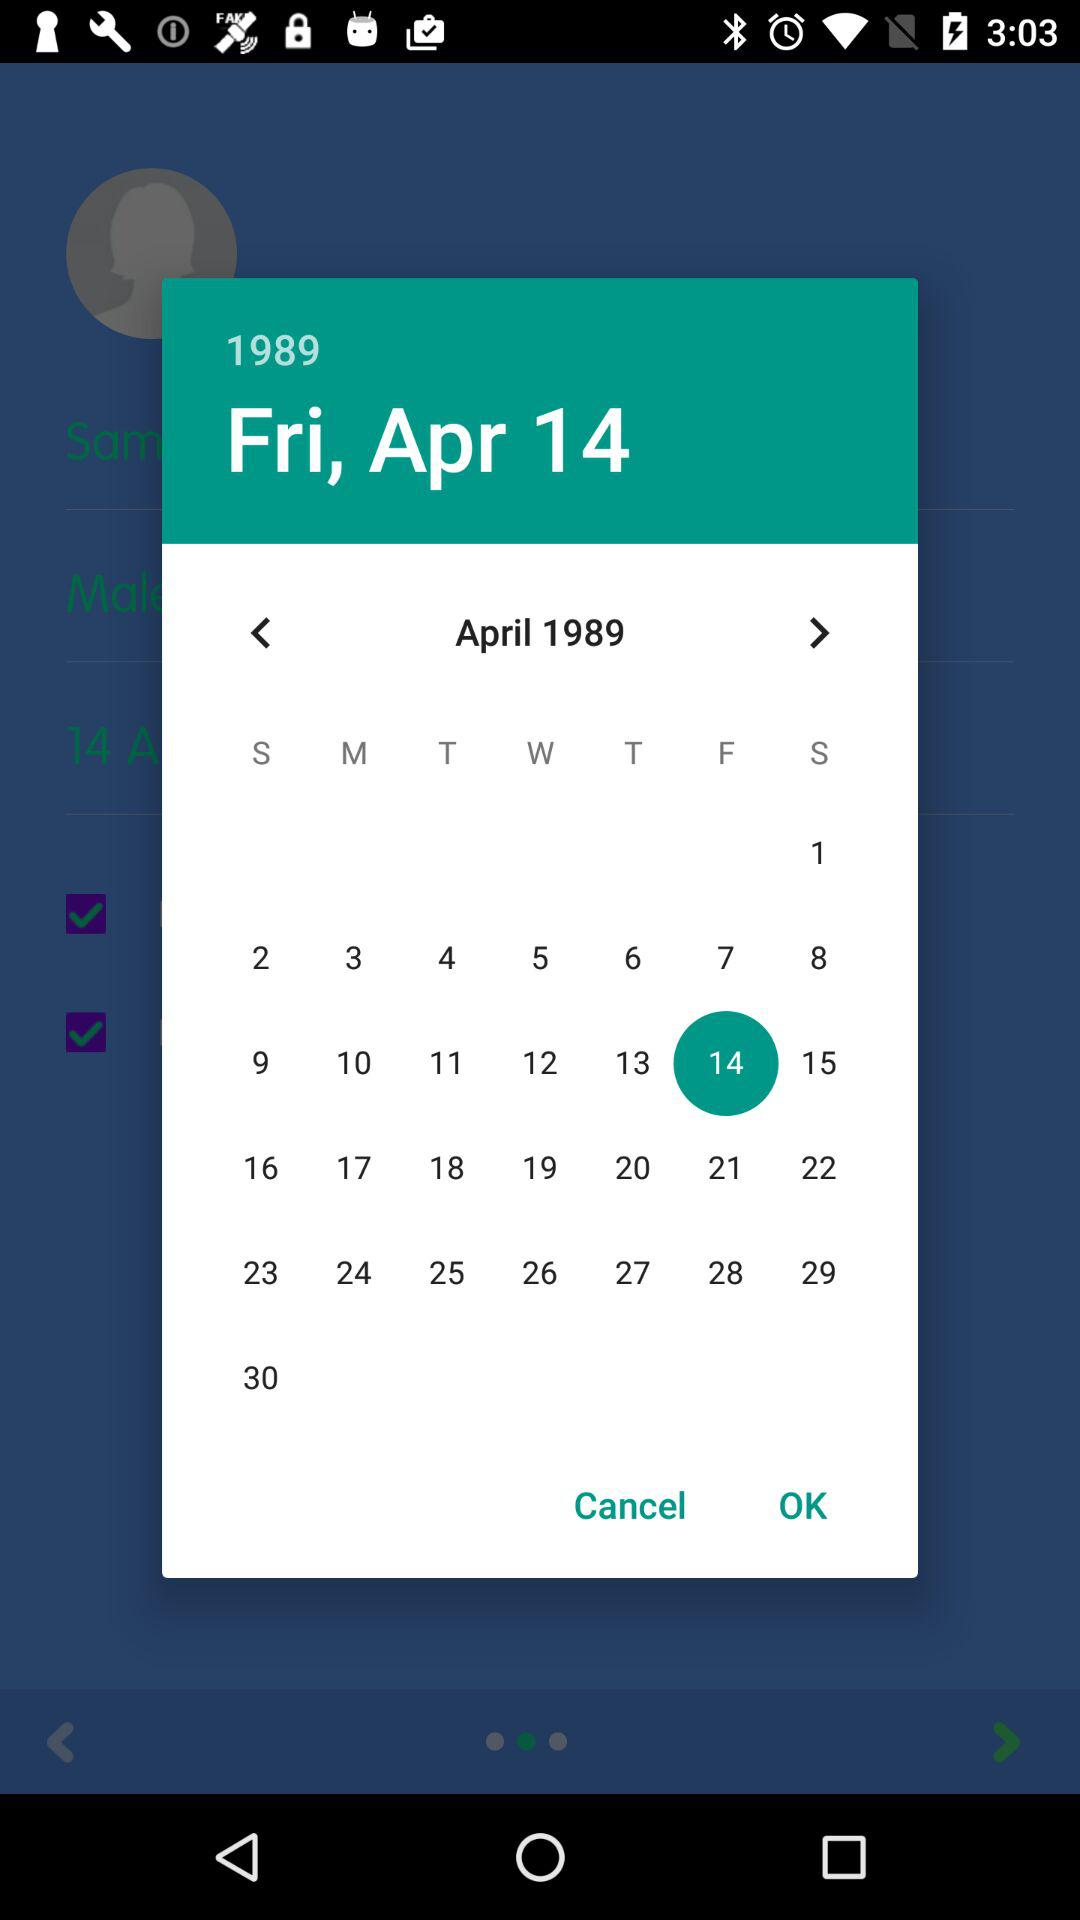Which day falls on April 4, 1989? The day is Tuesday. 